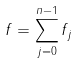Convert formula to latex. <formula><loc_0><loc_0><loc_500><loc_500>f = \sum _ { j = 0 } ^ { n - 1 } f _ { j }</formula> 